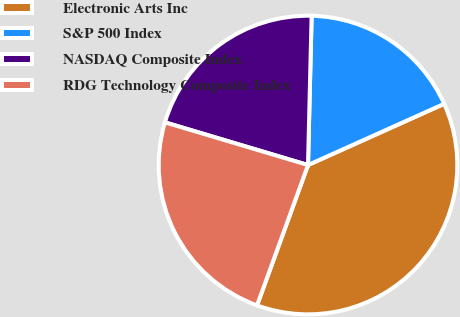Convert chart to OTSL. <chart><loc_0><loc_0><loc_500><loc_500><pie_chart><fcel>Electronic Arts Inc<fcel>S&P 500 Index<fcel>NASDAQ Composite Index<fcel>RDG Technology Composite Index<nl><fcel>37.27%<fcel>17.89%<fcel>20.77%<fcel>24.07%<nl></chart> 